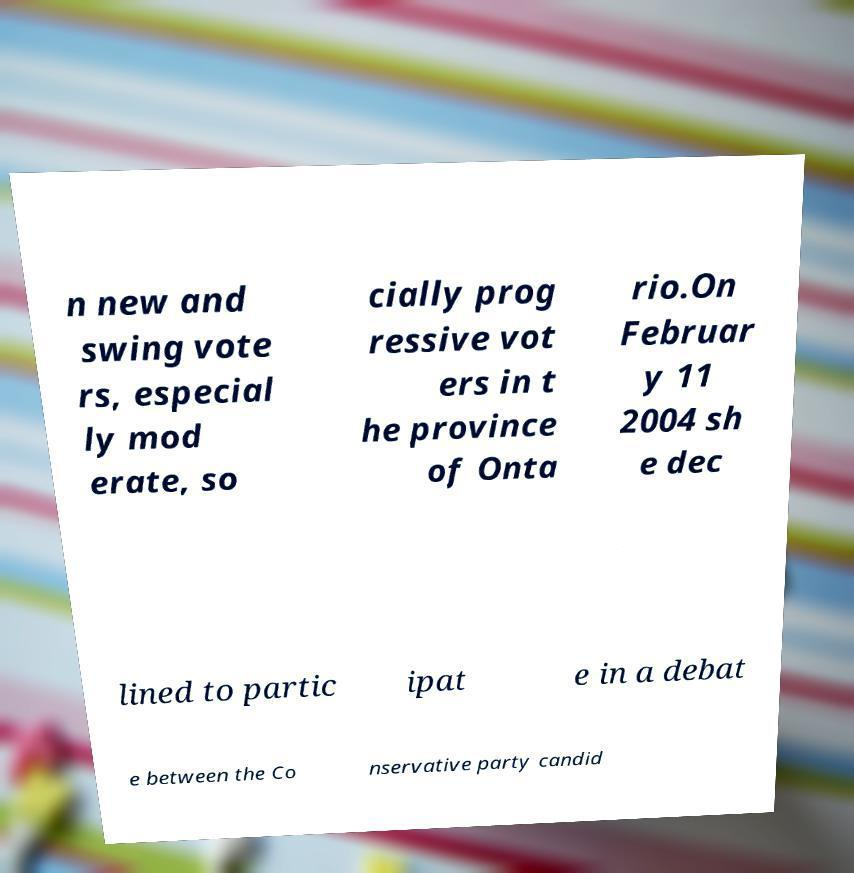Please identify and transcribe the text found in this image. n new and swing vote rs, especial ly mod erate, so cially prog ressive vot ers in t he province of Onta rio.On Februar y 11 2004 sh e dec lined to partic ipat e in a debat e between the Co nservative party candid 